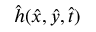<formula> <loc_0><loc_0><loc_500><loc_500>\hat { h } ( \hat { x } , \hat { y } , \hat { t } )</formula> 